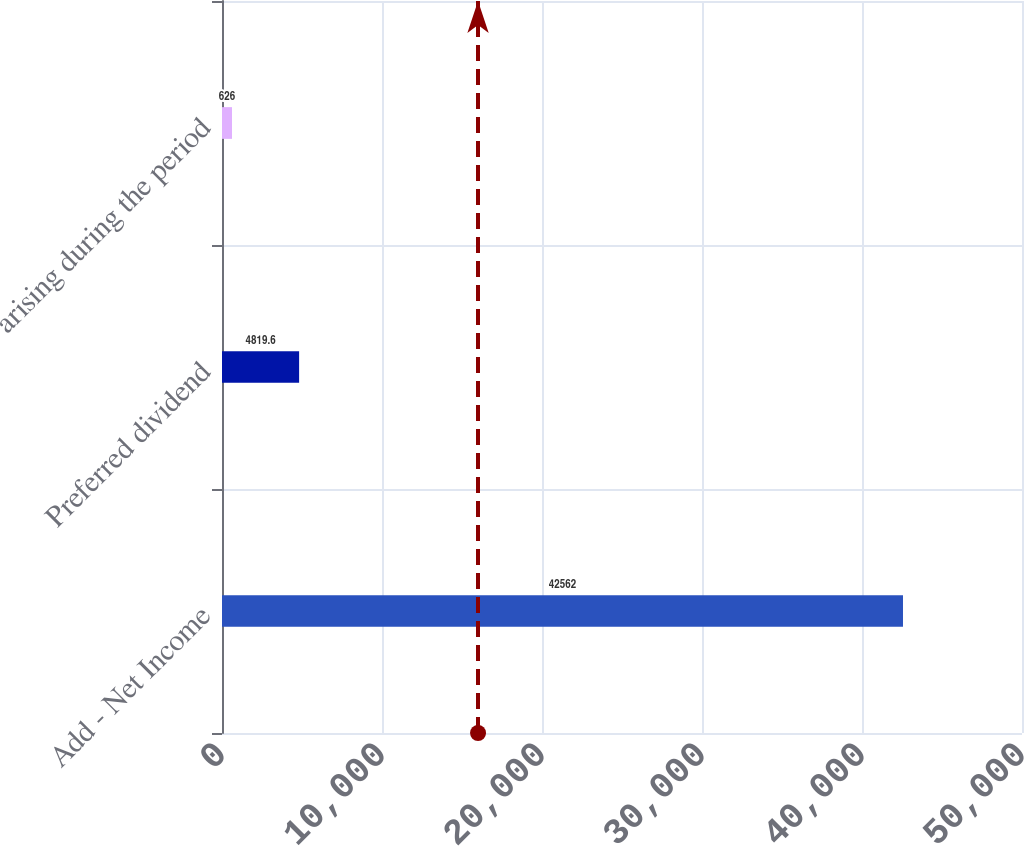Convert chart to OTSL. <chart><loc_0><loc_0><loc_500><loc_500><bar_chart><fcel>Add - Net Income<fcel>Preferred dividend<fcel>arising during the period<nl><fcel>42562<fcel>4819.6<fcel>626<nl></chart> 